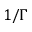Convert formula to latex. <formula><loc_0><loc_0><loc_500><loc_500>1 / \Gamma</formula> 